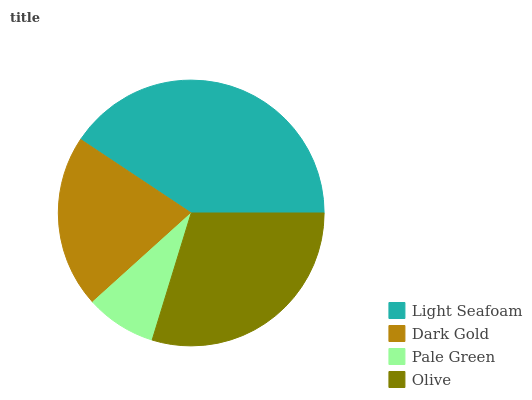Is Pale Green the minimum?
Answer yes or no. Yes. Is Light Seafoam the maximum?
Answer yes or no. Yes. Is Dark Gold the minimum?
Answer yes or no. No. Is Dark Gold the maximum?
Answer yes or no. No. Is Light Seafoam greater than Dark Gold?
Answer yes or no. Yes. Is Dark Gold less than Light Seafoam?
Answer yes or no. Yes. Is Dark Gold greater than Light Seafoam?
Answer yes or no. No. Is Light Seafoam less than Dark Gold?
Answer yes or no. No. Is Olive the high median?
Answer yes or no. Yes. Is Dark Gold the low median?
Answer yes or no. Yes. Is Dark Gold the high median?
Answer yes or no. No. Is Light Seafoam the low median?
Answer yes or no. No. 